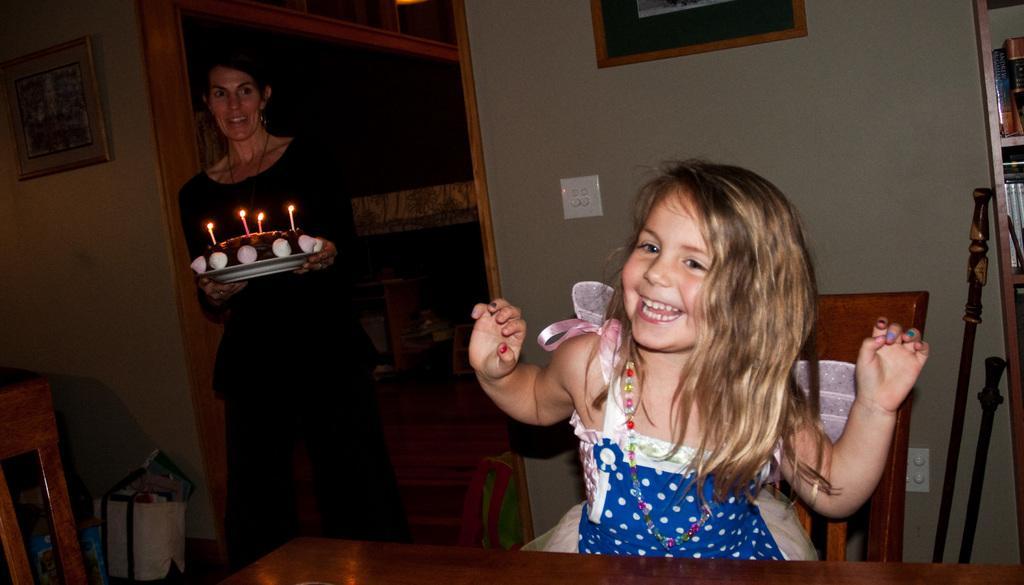Please provide a concise description of this image. In this image we can see a girl is sitting on a chair at the table and on the right side we can see a woman is holding a plate with candles on the cake on it. In the background there are frames on the wall, bags, books on the racks, wooden sticks, chairs and other objects. 